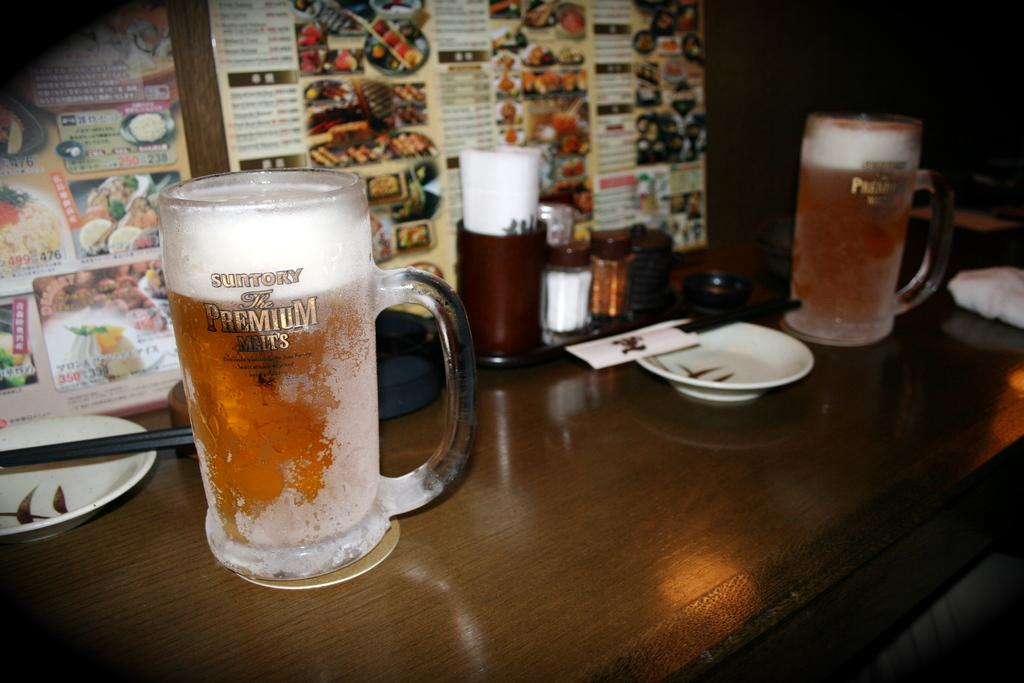Provide a one-sentence caption for the provided image. Two mugs of Suntory premium malt sitting on a wooden table. 